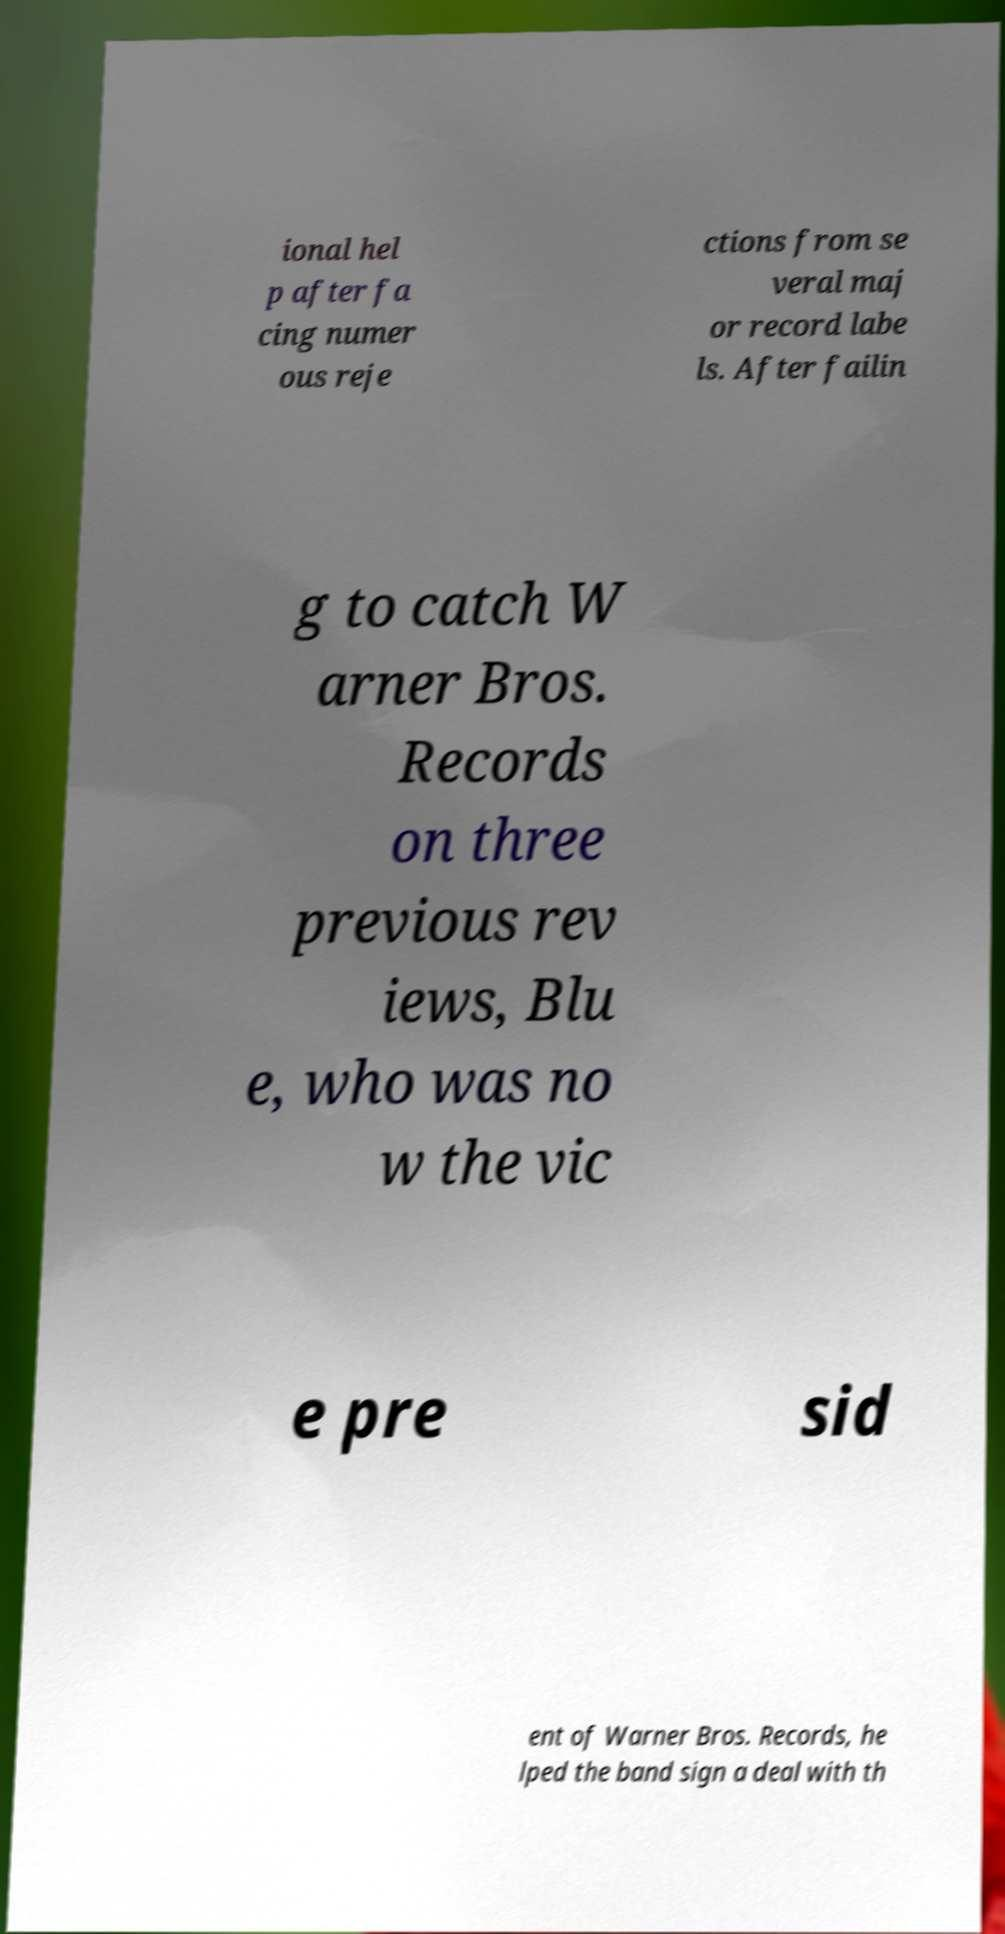Could you extract and type out the text from this image? ional hel p after fa cing numer ous reje ctions from se veral maj or record labe ls. After failin g to catch W arner Bros. Records on three previous rev iews, Blu e, who was no w the vic e pre sid ent of Warner Bros. Records, he lped the band sign a deal with th 